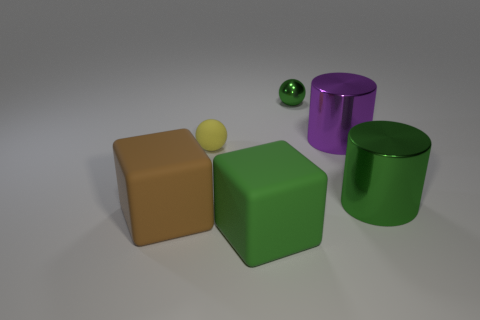Is the color of the matte ball the same as the big metal thing that is behind the large green shiny thing?
Offer a terse response. No. Are there any green things that have the same material as the yellow ball?
Offer a terse response. Yes. How many purple things are there?
Your answer should be compact. 1. There is a big cylinder behind the large object to the right of the purple cylinder; what is it made of?
Offer a very short reply. Metal. What color is the ball that is made of the same material as the purple cylinder?
Give a very brief answer. Green. What is the shape of the rubber thing that is the same color as the metal ball?
Keep it short and to the point. Cube. Does the cylinder behind the green cylinder have the same size as the green thing that is behind the big purple cylinder?
Your response must be concise. No. What number of blocks are either tiny red matte objects or brown objects?
Offer a terse response. 1. Is the material of the big block that is right of the brown block the same as the brown block?
Ensure brevity in your answer.  Yes. What number of other objects are the same size as the yellow thing?
Your answer should be very brief. 1. 